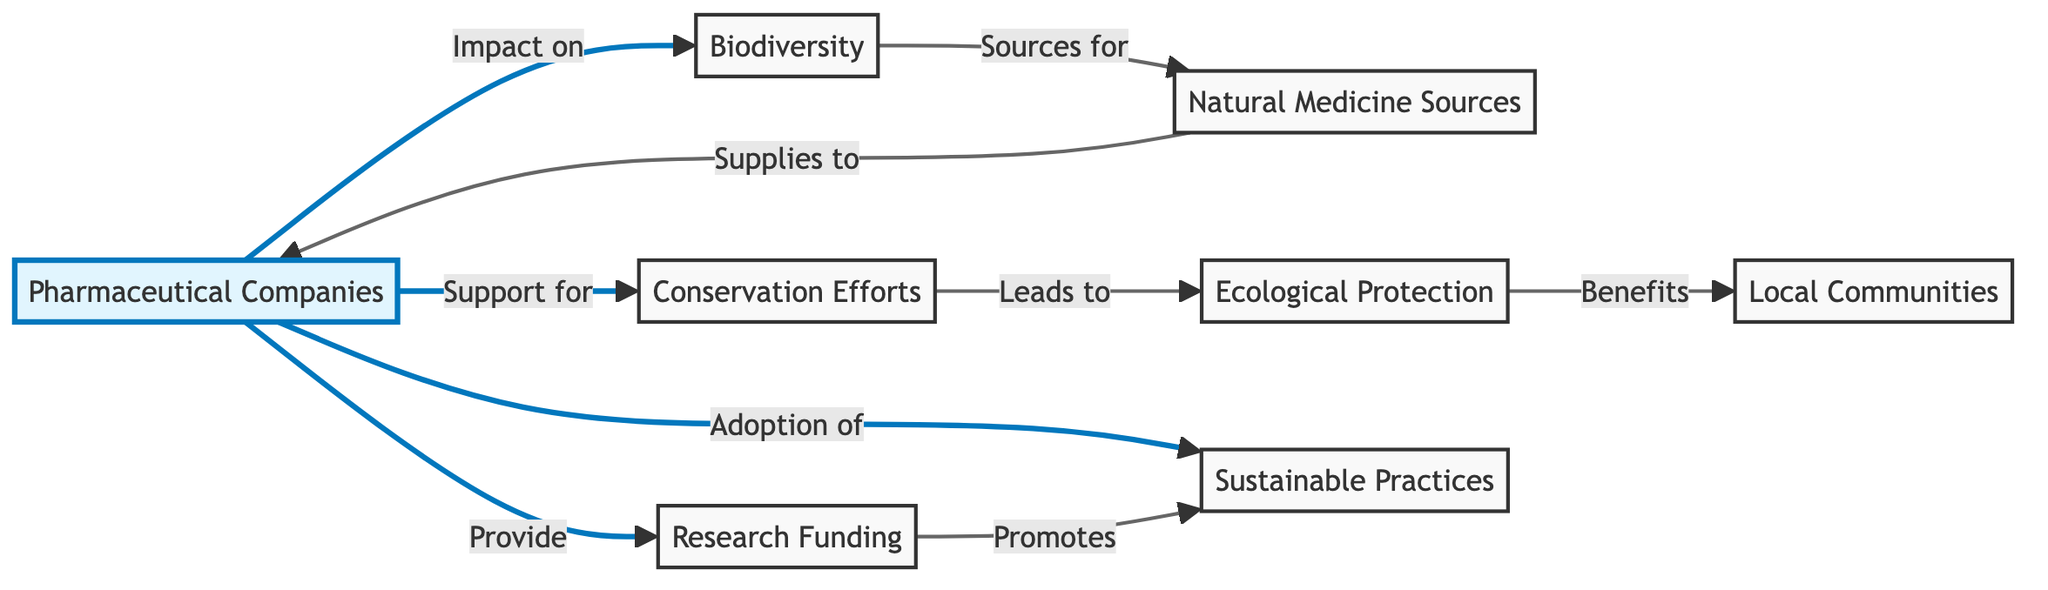What is the main entity represented in the diagram? The main entity is highlighted as "Pharmaceutical Companies," indicating its primary role in the relationships depicted.
Answer: Pharmaceutical Companies How many unique nodes are present in the diagram? The diagram includes six unique nodes: Pharmaceutical Companies, Biodiversity, Conservation Efforts, Natural Medicine Sources, Ecological Protection, and Local Communities.
Answer: 6 What is the relationship between Pharmaceutical Companies and Biodiversity? The relationship indicates an "Impact on" Biodiversity from Pharmaceutical Companies, demonstrating their influence or effect on this aspect.
Answer: Impact on Which node benefits from Ecological Protection? According to the connections drawn in the diagram, Local Communities benefit from Ecological Protection, showing the positive effects of such measures.
Answer: Local Communities What do Pharmaceutical Companies provide according to the diagram? The diagram states that Pharmaceutical Companies provide Research Funding, indicating a specific way they contribute to the ecosystem.
Answer: Research Funding How do Natural Medicine Sources relate to Biodiversity? Natural Medicine Sources are described as "Sources for" Biodiversity, signifying that biodiversity contributes to the availability of natural medicines.
Answer: Sources for What is the impact of Research Funding on Sustainable Practices? Research Funding is indicated to "Promote" Sustainable Practices, implying a supportive role in adopting eco-friendly methods.
Answer: Promotes How does Conservation Efforts relate to Ecological Protection? The relationship shows that Conservation Efforts "Leads to" Ecological Protection, demonstrating a sequential benefit between these two nodes.
Answer: Leads to What do Sustainable Practices benefit according to the diagram? Sustainable Practices benefit Local Communities as highlighted in the flow of the diagram, emphasizing their importance for community health and viability.
Answer: Local Communities 